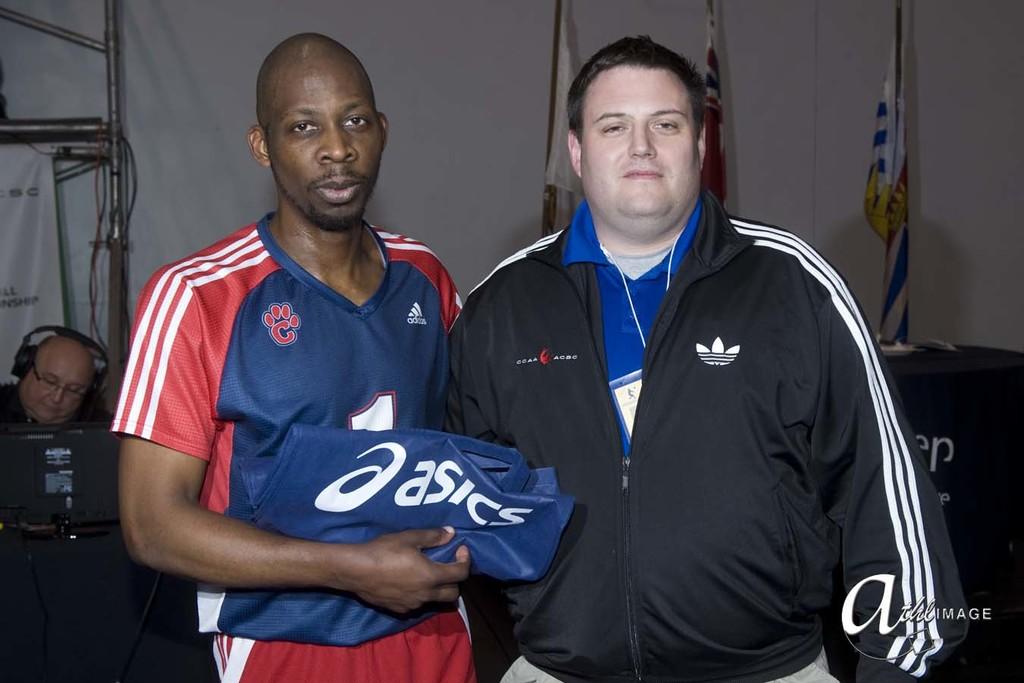What is written on the top line?
Provide a short and direct response. Unanswerable. 